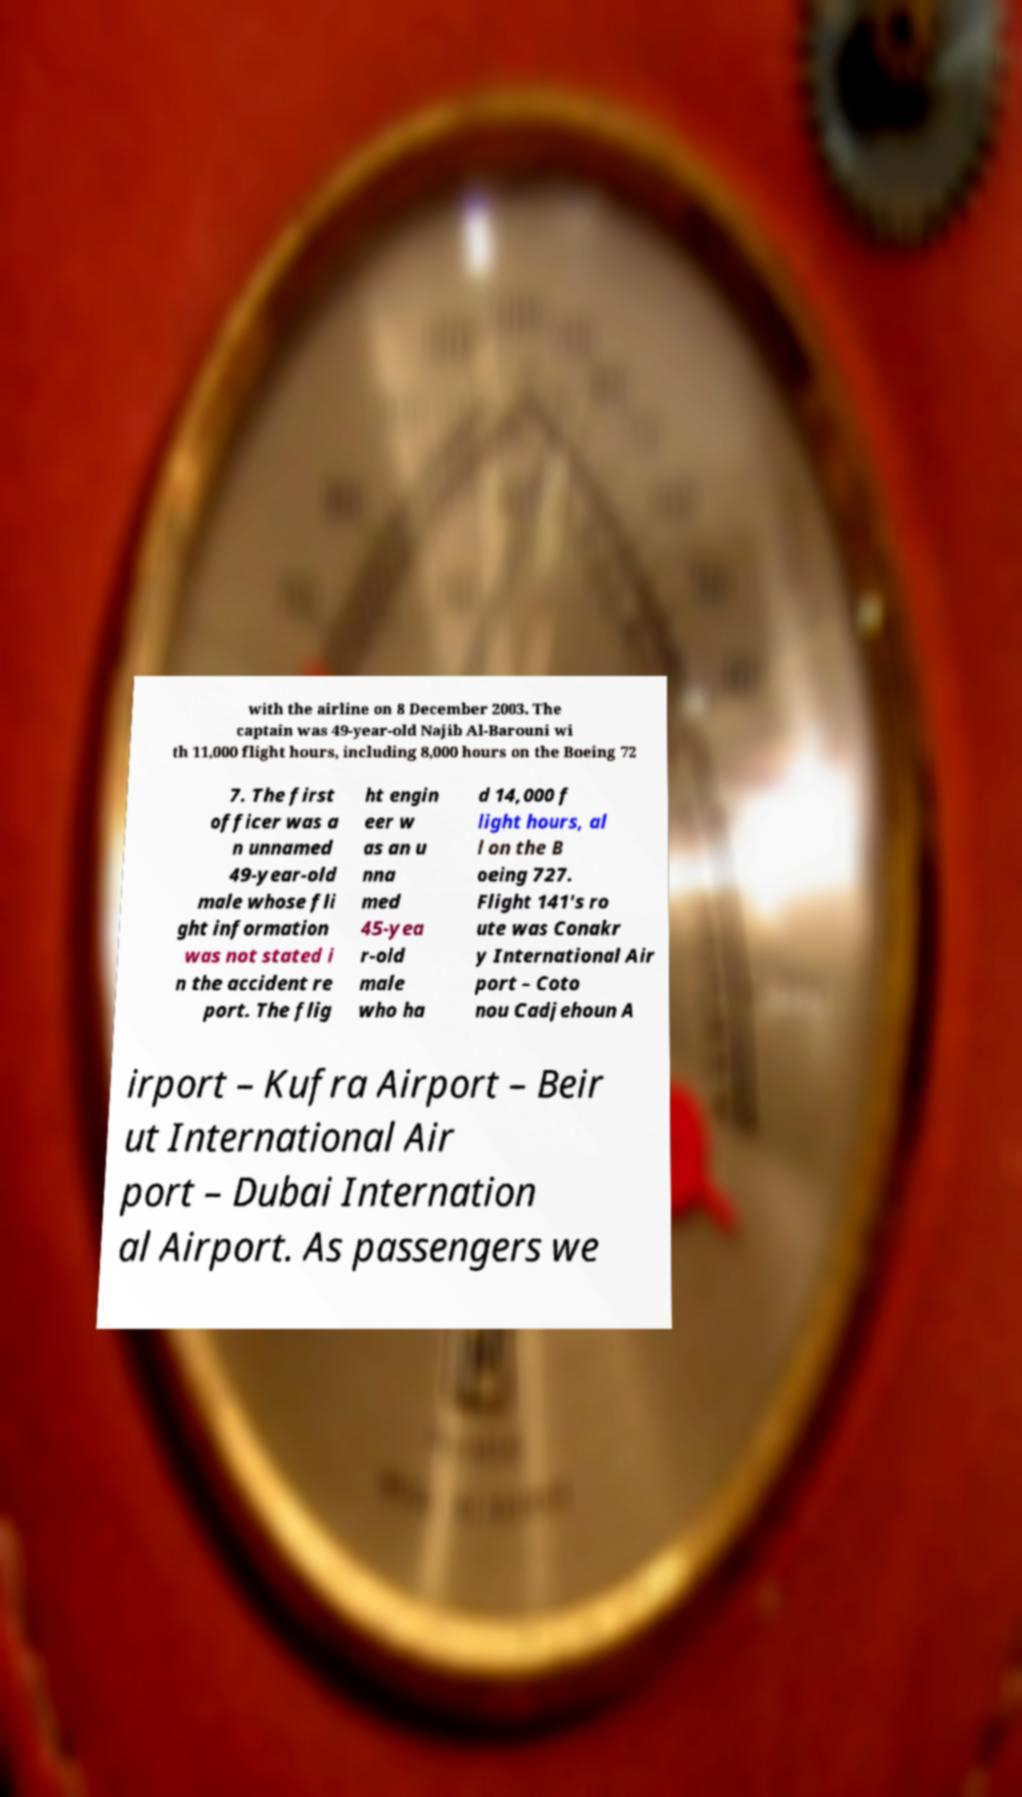Can you accurately transcribe the text from the provided image for me? with the airline on 8 December 2003. The captain was 49-year-old Najib Al-Barouni wi th 11,000 flight hours, including 8,000 hours on the Boeing 72 7. The first officer was a n unnamed 49-year-old male whose fli ght information was not stated i n the accident re port. The flig ht engin eer w as an u nna med 45-yea r-old male who ha d 14,000 f light hours, al l on the B oeing 727. Flight 141's ro ute was Conakr y International Air port – Coto nou Cadjehoun A irport – Kufra Airport – Beir ut International Air port – Dubai Internation al Airport. As passengers we 